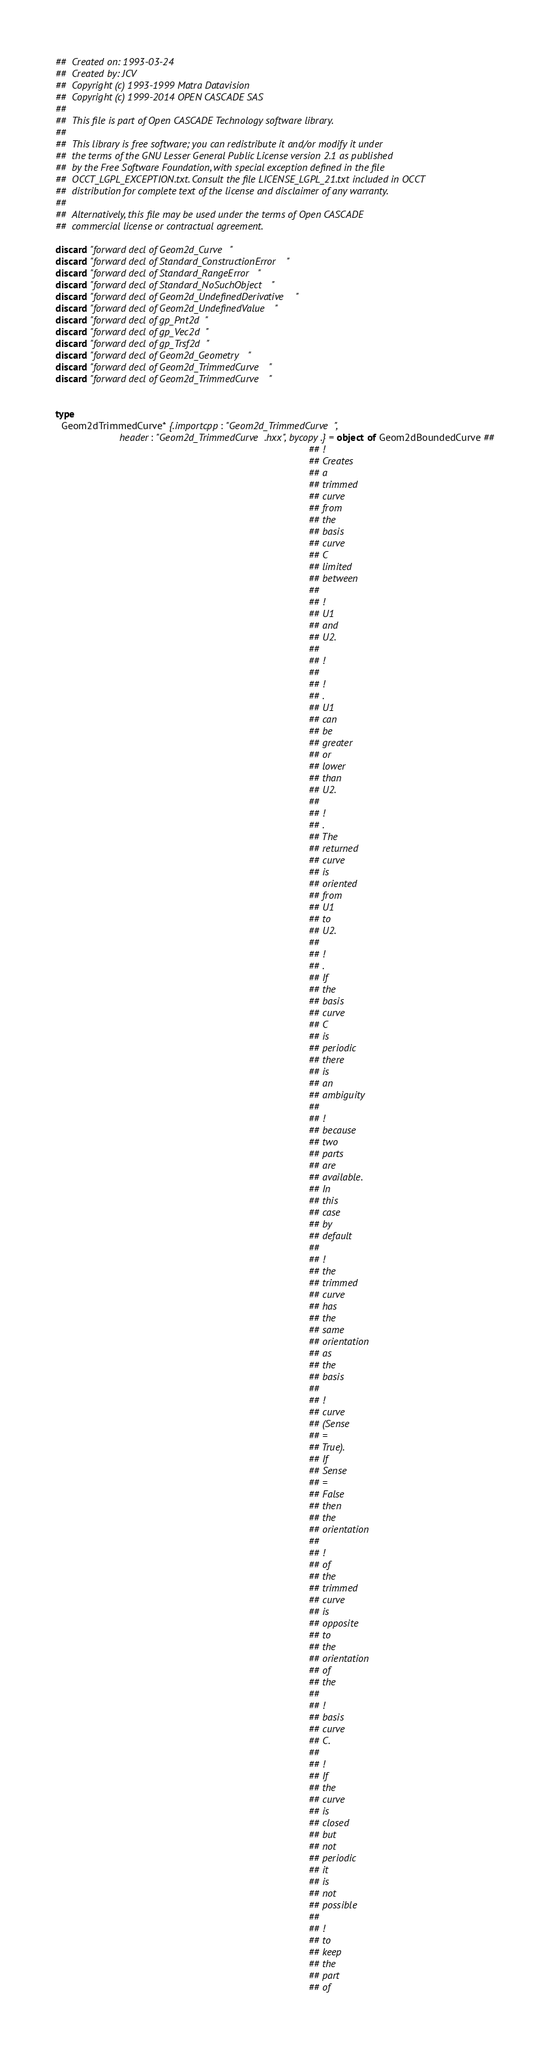<code> <loc_0><loc_0><loc_500><loc_500><_Nim_>##  Created on: 1993-03-24
##  Created by: JCV
##  Copyright (c) 1993-1999 Matra Datavision
##  Copyright (c) 1999-2014 OPEN CASCADE SAS
##
##  This file is part of Open CASCADE Technology software library.
##
##  This library is free software; you can redistribute it and/or modify it under
##  the terms of the GNU Lesser General Public License version 2.1 as published
##  by the Free Software Foundation, with special exception defined in the file
##  OCCT_LGPL_EXCEPTION.txt. Consult the file LICENSE_LGPL_21.txt included in OCCT
##  distribution for complete text of the license and disclaimer of any warranty.
##
##  Alternatively, this file may be used under the terms of Open CASCADE
##  commercial license or contractual agreement.

discard "forward decl of Geom2d_Curve"
discard "forward decl of Standard_ConstructionError"
discard "forward decl of Standard_RangeError"
discard "forward decl of Standard_NoSuchObject"
discard "forward decl of Geom2d_UndefinedDerivative"
discard "forward decl of Geom2d_UndefinedValue"
discard "forward decl of gp_Pnt2d"
discard "forward decl of gp_Vec2d"
discard "forward decl of gp_Trsf2d"
discard "forward decl of Geom2d_Geometry"
discard "forward decl of Geom2d_TrimmedCurve"
discard "forward decl of Geom2d_TrimmedCurve"


type
  Geom2dTrimmedCurve* {.importcpp: "Geom2d_TrimmedCurve",
                       header: "Geom2d_TrimmedCurve.hxx", bycopy.} = object of Geom2dBoundedCurve ##
                                                                                           ## !
                                                                                           ## Creates
                                                                                           ## a
                                                                                           ## trimmed
                                                                                           ## curve
                                                                                           ## from
                                                                                           ## the
                                                                                           ## basis
                                                                                           ## curve
                                                                                           ## C
                                                                                           ## limited
                                                                                           ## between
                                                                                           ##
                                                                                           ## !
                                                                                           ## U1
                                                                                           ## and
                                                                                           ## U2.
                                                                                           ##
                                                                                           ## !
                                                                                           ##
                                                                                           ## !
                                                                                           ## .
                                                                                           ## U1
                                                                                           ## can
                                                                                           ## be
                                                                                           ## greater
                                                                                           ## or
                                                                                           ## lower
                                                                                           ## than
                                                                                           ## U2.
                                                                                           ##
                                                                                           ## !
                                                                                           ## .
                                                                                           ## The
                                                                                           ## returned
                                                                                           ## curve
                                                                                           ## is
                                                                                           ## oriented
                                                                                           ## from
                                                                                           ## U1
                                                                                           ## to
                                                                                           ## U2.
                                                                                           ##
                                                                                           ## !
                                                                                           ## .
                                                                                           ## If
                                                                                           ## the
                                                                                           ## basis
                                                                                           ## curve
                                                                                           ## C
                                                                                           ## is
                                                                                           ## periodic
                                                                                           ## there
                                                                                           ## is
                                                                                           ## an
                                                                                           ## ambiguity
                                                                                           ##
                                                                                           ## !
                                                                                           ## because
                                                                                           ## two
                                                                                           ## parts
                                                                                           ## are
                                                                                           ## available.
                                                                                           ## In
                                                                                           ## this
                                                                                           ## case
                                                                                           ## by
                                                                                           ## default
                                                                                           ##
                                                                                           ## !
                                                                                           ## the
                                                                                           ## trimmed
                                                                                           ## curve
                                                                                           ## has
                                                                                           ## the
                                                                                           ## same
                                                                                           ## orientation
                                                                                           ## as
                                                                                           ## the
                                                                                           ## basis
                                                                                           ##
                                                                                           ## !
                                                                                           ## curve
                                                                                           ## (Sense
                                                                                           ## =
                                                                                           ## True).
                                                                                           ## If
                                                                                           ## Sense
                                                                                           ## =
                                                                                           ## False
                                                                                           ## then
                                                                                           ## the
                                                                                           ## orientation
                                                                                           ##
                                                                                           ## !
                                                                                           ## of
                                                                                           ## the
                                                                                           ## trimmed
                                                                                           ## curve
                                                                                           ## is
                                                                                           ## opposite
                                                                                           ## to
                                                                                           ## the
                                                                                           ## orientation
                                                                                           ## of
                                                                                           ## the
                                                                                           ##
                                                                                           ## !
                                                                                           ## basis
                                                                                           ## curve
                                                                                           ## C.
                                                                                           ##
                                                                                           ## !
                                                                                           ## If
                                                                                           ## the
                                                                                           ## curve
                                                                                           ## is
                                                                                           ## closed
                                                                                           ## but
                                                                                           ## not
                                                                                           ## periodic
                                                                                           ## it
                                                                                           ## is
                                                                                           ## not
                                                                                           ## possible
                                                                                           ##
                                                                                           ## !
                                                                                           ## to
                                                                                           ## keep
                                                                                           ## the
                                                                                           ## part
                                                                                           ## of</code> 